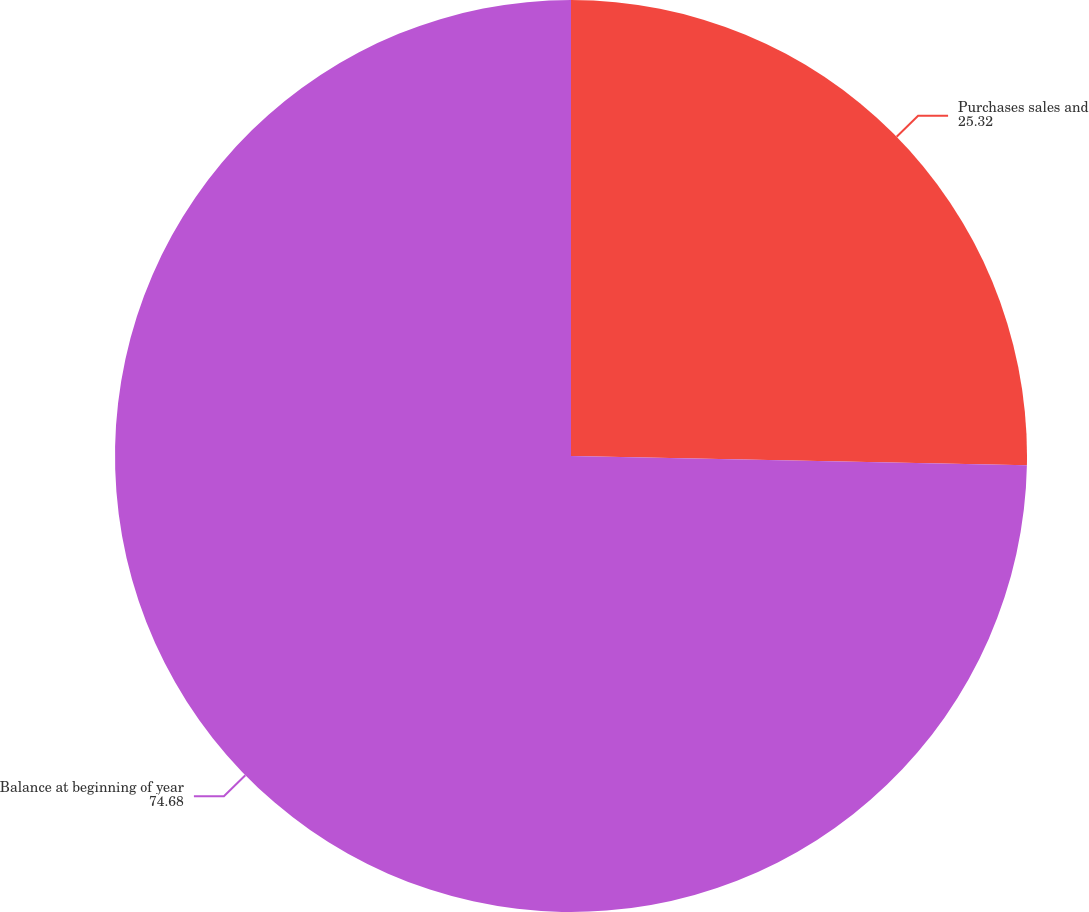Convert chart to OTSL. <chart><loc_0><loc_0><loc_500><loc_500><pie_chart><fcel>Purchases sales and<fcel>Balance at beginning of year<nl><fcel>25.32%<fcel>74.68%<nl></chart> 